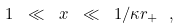<formula> <loc_0><loc_0><loc_500><loc_500>1 \ \ll \ x \ \ll \ 1 / \kappa r _ { + } \ ,</formula> 